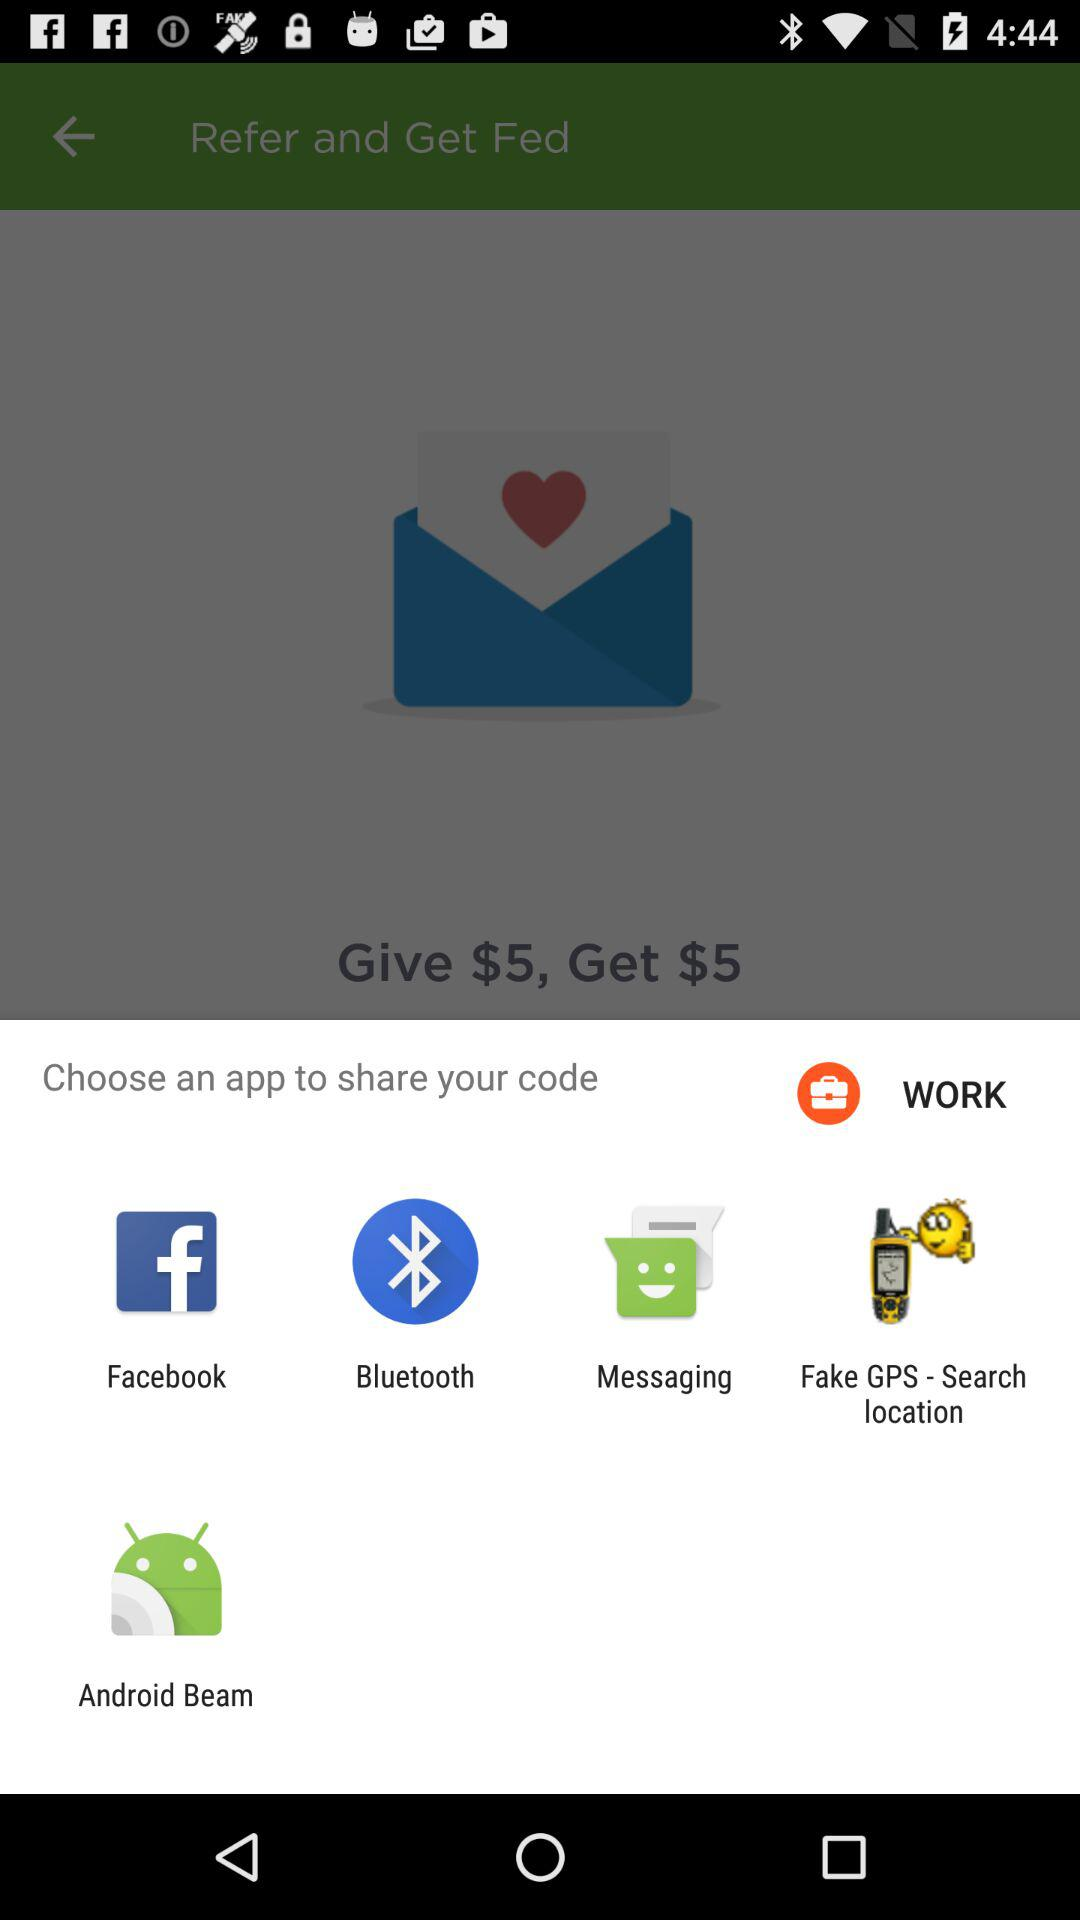What are the available options to share the code? The available options are "Facebook", "Bluetooth", "Messaging", "Fake GPS - Search location" and "Android Beam". 